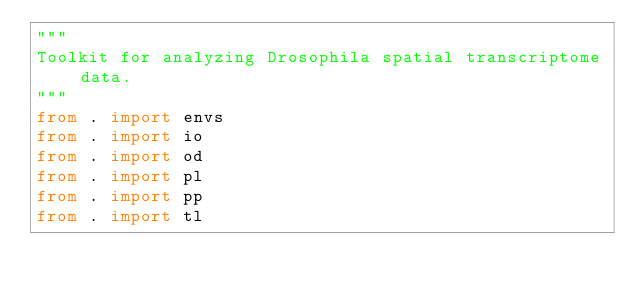<code> <loc_0><loc_0><loc_500><loc_500><_Python_>"""
Toolkit for analyzing Drosophila spatial transcriptome data.
"""
from . import envs
from . import io
from . import od
from . import pl
from . import pp
from . import tl
</code> 